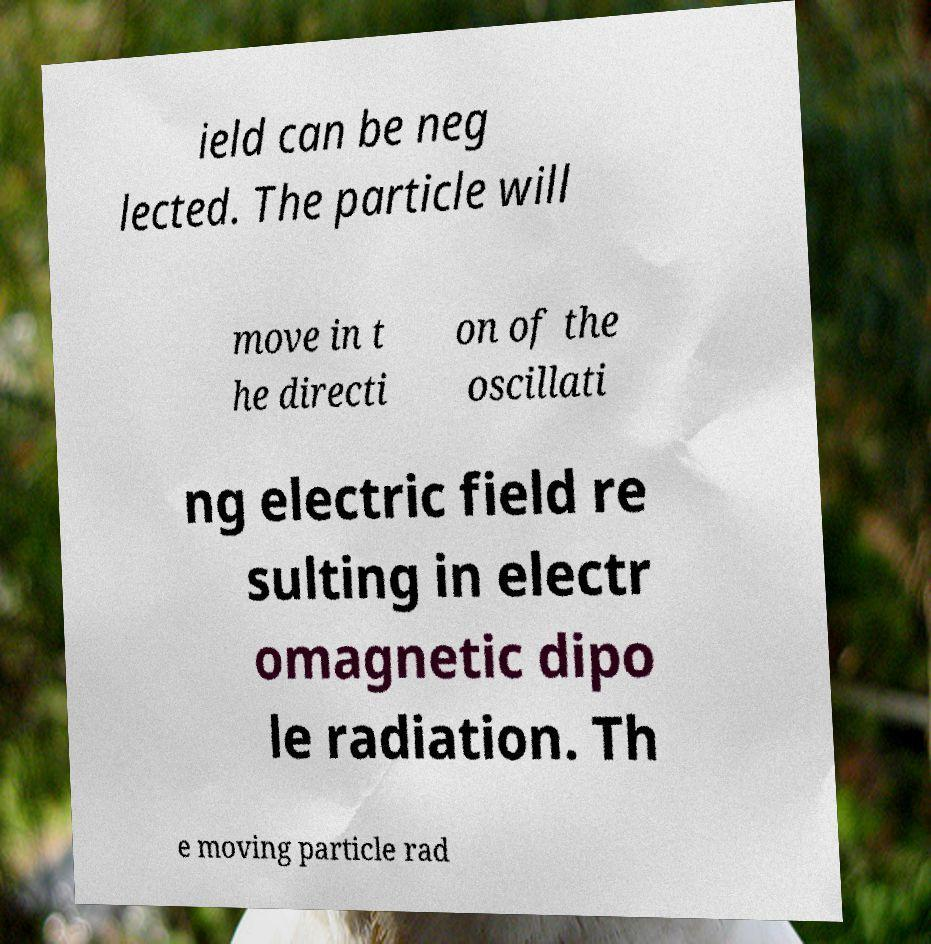There's text embedded in this image that I need extracted. Can you transcribe it verbatim? ield can be neg lected. The particle will move in t he directi on of the oscillati ng electric field re sulting in electr omagnetic dipo le radiation. Th e moving particle rad 